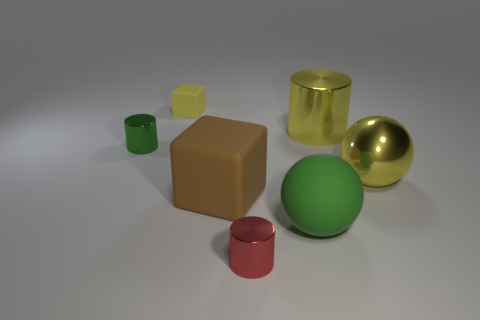What size is the yellow object that is the same shape as the big green thing?
Give a very brief answer. Large. What size is the cylinder that is the same color as the small matte thing?
Offer a very short reply. Large. The block that is behind the small metallic thing behind the ball behind the brown thing is made of what material?
Offer a terse response. Rubber. What is the shape of the small metal object that is behind the tiny red metallic cylinder?
Ensure brevity in your answer.  Cylinder. What size is the yellow sphere that is made of the same material as the red cylinder?
Offer a terse response. Large. What number of other small metal objects have the same shape as the small red shiny thing?
Ensure brevity in your answer.  1. There is a thing to the left of the tiny yellow thing; does it have the same color as the big matte ball?
Ensure brevity in your answer.  Yes. There is a metallic cylinder in front of the green object in front of the large shiny sphere; how many shiny cylinders are right of it?
Your response must be concise. 1. How many large things are both in front of the tiny green cylinder and to the left of the yellow metallic ball?
Ensure brevity in your answer.  2. What shape is the metallic thing that is the same color as the big cylinder?
Your response must be concise. Sphere. 